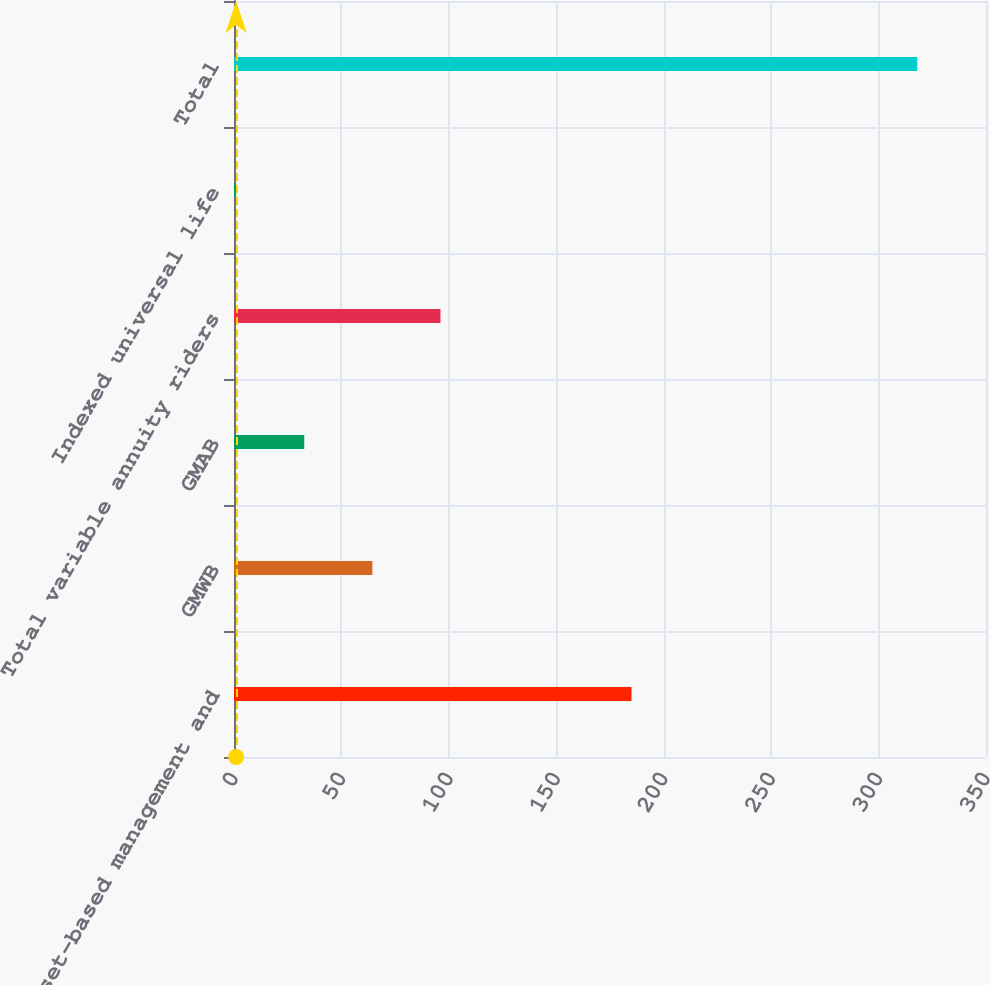Convert chart to OTSL. <chart><loc_0><loc_0><loc_500><loc_500><bar_chart><fcel>Asset-based management and<fcel>GMWB<fcel>GMAB<fcel>Total variable annuity riders<fcel>Indexed universal life<fcel>Total<nl><fcel>185<fcel>64.4<fcel>32.7<fcel>96.1<fcel>1<fcel>318<nl></chart> 